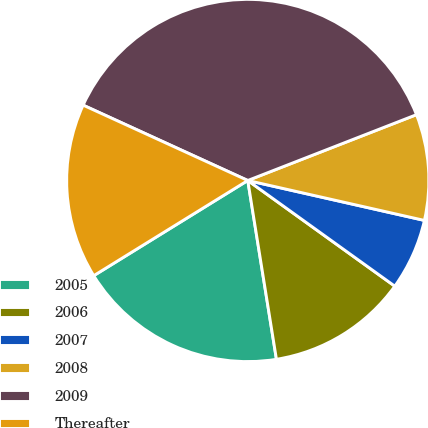Convert chart to OTSL. <chart><loc_0><loc_0><loc_500><loc_500><pie_chart><fcel>2005<fcel>2006<fcel>2007<fcel>2008<fcel>2009<fcel>Thereafter<nl><fcel>18.72%<fcel>12.55%<fcel>6.38%<fcel>9.46%<fcel>37.25%<fcel>15.64%<nl></chart> 